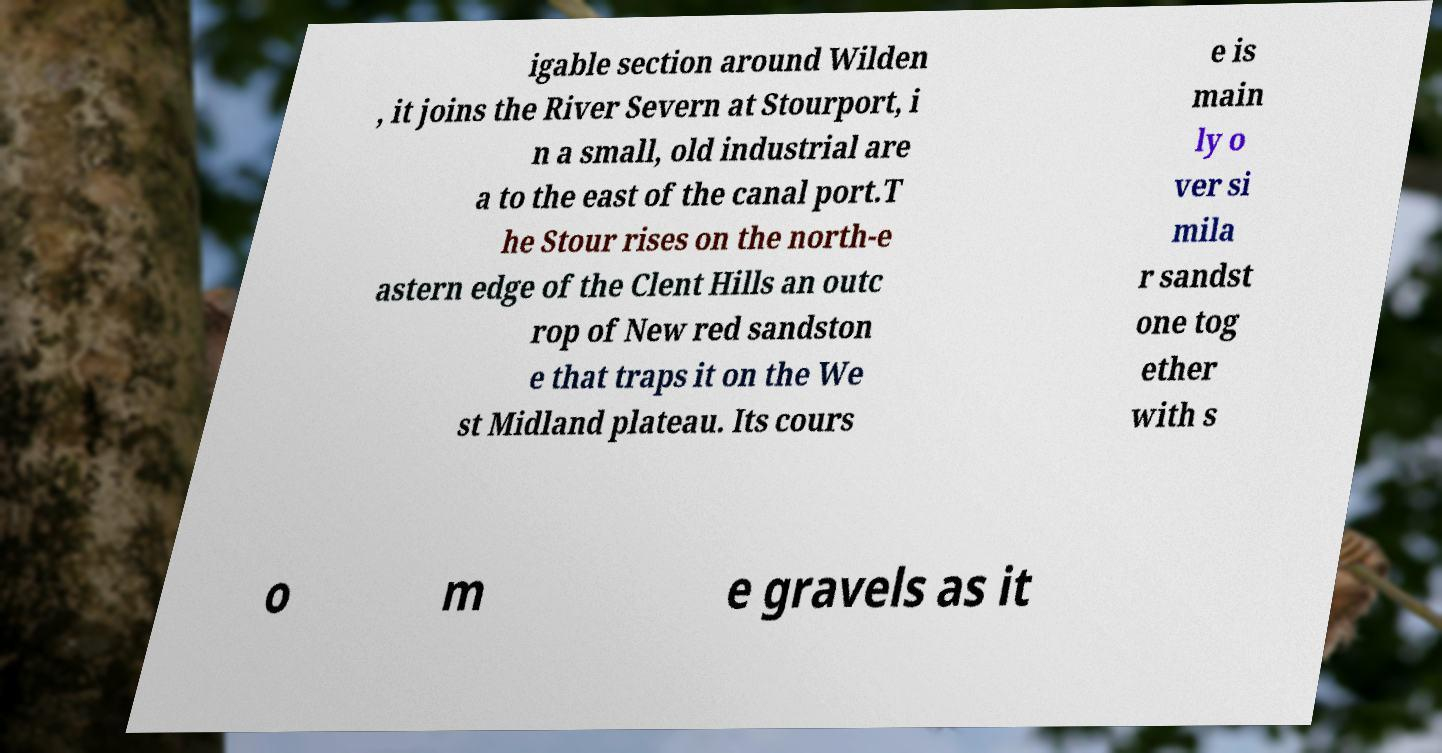What messages or text are displayed in this image? I need them in a readable, typed format. igable section around Wilden , it joins the River Severn at Stourport, i n a small, old industrial are a to the east of the canal port.T he Stour rises on the north-e astern edge of the Clent Hills an outc rop of New red sandston e that traps it on the We st Midland plateau. Its cours e is main ly o ver si mila r sandst one tog ether with s o m e gravels as it 